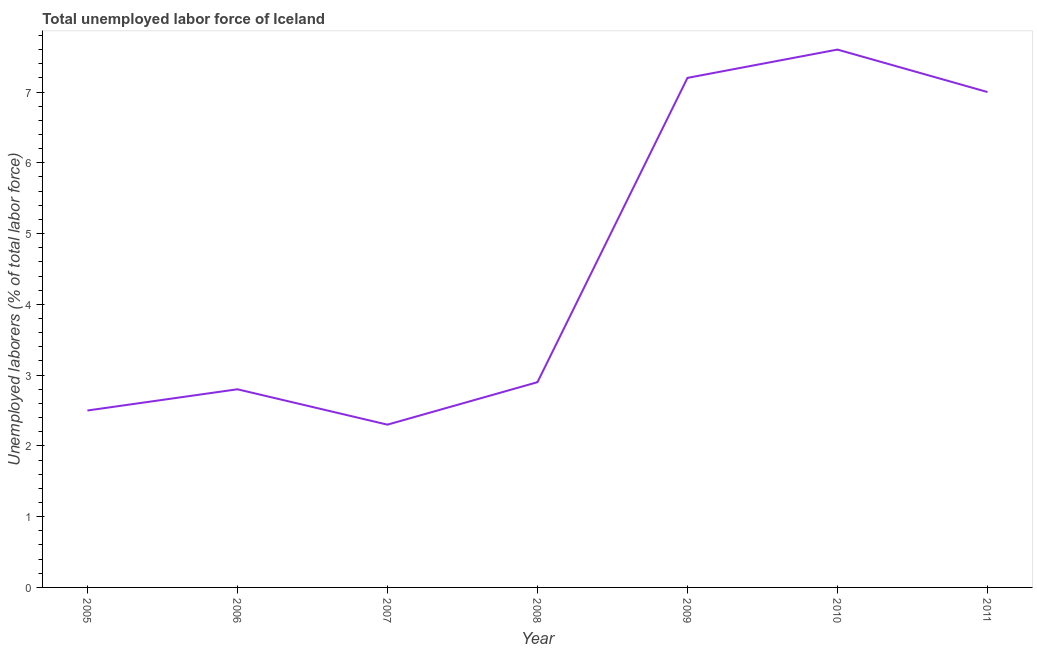What is the total unemployed labour force in 2009?
Make the answer very short. 7.2. Across all years, what is the maximum total unemployed labour force?
Give a very brief answer. 7.6. Across all years, what is the minimum total unemployed labour force?
Offer a very short reply. 2.3. In which year was the total unemployed labour force minimum?
Your answer should be compact. 2007. What is the sum of the total unemployed labour force?
Keep it short and to the point. 32.3. What is the difference between the total unemployed labour force in 2006 and 2008?
Keep it short and to the point. -0.1. What is the average total unemployed labour force per year?
Ensure brevity in your answer.  4.61. What is the median total unemployed labour force?
Provide a short and direct response. 2.9. What is the ratio of the total unemployed labour force in 2010 to that in 2011?
Make the answer very short. 1.09. Is the total unemployed labour force in 2005 less than that in 2009?
Give a very brief answer. Yes. What is the difference between the highest and the second highest total unemployed labour force?
Make the answer very short. 0.4. What is the difference between the highest and the lowest total unemployed labour force?
Offer a terse response. 5.3. Does the total unemployed labour force monotonically increase over the years?
Your response must be concise. No. How many lines are there?
Make the answer very short. 1. How many years are there in the graph?
Provide a short and direct response. 7. What is the difference between two consecutive major ticks on the Y-axis?
Offer a terse response. 1. Does the graph contain grids?
Make the answer very short. No. What is the title of the graph?
Make the answer very short. Total unemployed labor force of Iceland. What is the label or title of the X-axis?
Ensure brevity in your answer.  Year. What is the label or title of the Y-axis?
Give a very brief answer. Unemployed laborers (% of total labor force). What is the Unemployed laborers (% of total labor force) of 2005?
Offer a very short reply. 2.5. What is the Unemployed laborers (% of total labor force) of 2006?
Provide a short and direct response. 2.8. What is the Unemployed laborers (% of total labor force) in 2007?
Offer a very short reply. 2.3. What is the Unemployed laborers (% of total labor force) in 2008?
Your answer should be compact. 2.9. What is the Unemployed laborers (% of total labor force) in 2009?
Your response must be concise. 7.2. What is the Unemployed laborers (% of total labor force) in 2010?
Make the answer very short. 7.6. What is the difference between the Unemployed laborers (% of total labor force) in 2005 and 2007?
Your answer should be very brief. 0.2. What is the difference between the Unemployed laborers (% of total labor force) in 2005 and 2010?
Provide a succinct answer. -5.1. What is the difference between the Unemployed laborers (% of total labor force) in 2005 and 2011?
Make the answer very short. -4.5. What is the difference between the Unemployed laborers (% of total labor force) in 2006 and 2007?
Provide a short and direct response. 0.5. What is the difference between the Unemployed laborers (% of total labor force) in 2006 and 2009?
Provide a succinct answer. -4.4. What is the difference between the Unemployed laborers (% of total labor force) in 2006 and 2011?
Offer a terse response. -4.2. What is the difference between the Unemployed laborers (% of total labor force) in 2007 and 2011?
Provide a short and direct response. -4.7. What is the difference between the Unemployed laborers (% of total labor force) in 2008 and 2009?
Provide a short and direct response. -4.3. What is the difference between the Unemployed laborers (% of total labor force) in 2008 and 2011?
Ensure brevity in your answer.  -4.1. What is the difference between the Unemployed laborers (% of total labor force) in 2010 and 2011?
Keep it short and to the point. 0.6. What is the ratio of the Unemployed laborers (% of total labor force) in 2005 to that in 2006?
Offer a terse response. 0.89. What is the ratio of the Unemployed laborers (% of total labor force) in 2005 to that in 2007?
Provide a succinct answer. 1.09. What is the ratio of the Unemployed laborers (% of total labor force) in 2005 to that in 2008?
Offer a terse response. 0.86. What is the ratio of the Unemployed laborers (% of total labor force) in 2005 to that in 2009?
Ensure brevity in your answer.  0.35. What is the ratio of the Unemployed laborers (% of total labor force) in 2005 to that in 2010?
Give a very brief answer. 0.33. What is the ratio of the Unemployed laborers (% of total labor force) in 2005 to that in 2011?
Your response must be concise. 0.36. What is the ratio of the Unemployed laborers (% of total labor force) in 2006 to that in 2007?
Offer a very short reply. 1.22. What is the ratio of the Unemployed laborers (% of total labor force) in 2006 to that in 2009?
Your answer should be very brief. 0.39. What is the ratio of the Unemployed laborers (% of total labor force) in 2006 to that in 2010?
Provide a short and direct response. 0.37. What is the ratio of the Unemployed laborers (% of total labor force) in 2006 to that in 2011?
Your answer should be very brief. 0.4. What is the ratio of the Unemployed laborers (% of total labor force) in 2007 to that in 2008?
Make the answer very short. 0.79. What is the ratio of the Unemployed laborers (% of total labor force) in 2007 to that in 2009?
Offer a terse response. 0.32. What is the ratio of the Unemployed laborers (% of total labor force) in 2007 to that in 2010?
Give a very brief answer. 0.3. What is the ratio of the Unemployed laborers (% of total labor force) in 2007 to that in 2011?
Your answer should be very brief. 0.33. What is the ratio of the Unemployed laborers (% of total labor force) in 2008 to that in 2009?
Provide a short and direct response. 0.4. What is the ratio of the Unemployed laborers (% of total labor force) in 2008 to that in 2010?
Your response must be concise. 0.38. What is the ratio of the Unemployed laborers (% of total labor force) in 2008 to that in 2011?
Keep it short and to the point. 0.41. What is the ratio of the Unemployed laborers (% of total labor force) in 2009 to that in 2010?
Your response must be concise. 0.95. What is the ratio of the Unemployed laborers (% of total labor force) in 2010 to that in 2011?
Offer a terse response. 1.09. 